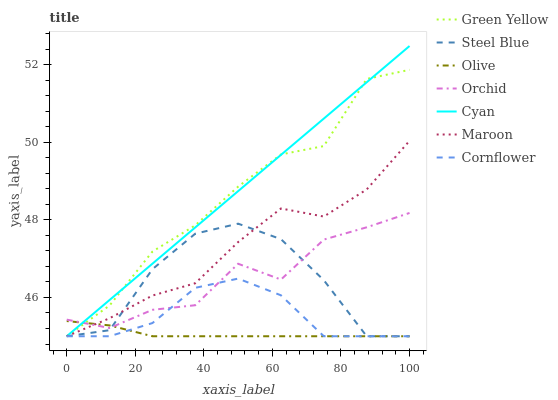Does Olive have the minimum area under the curve?
Answer yes or no. Yes. Does Cyan have the maximum area under the curve?
Answer yes or no. Yes. Does Steel Blue have the minimum area under the curve?
Answer yes or no. No. Does Steel Blue have the maximum area under the curve?
Answer yes or no. No. Is Cyan the smoothest?
Answer yes or no. Yes. Is Steel Blue the roughest?
Answer yes or no. Yes. Is Maroon the smoothest?
Answer yes or no. No. Is Maroon the roughest?
Answer yes or no. No. Does Cornflower have the lowest value?
Answer yes or no. Yes. Does Orchid have the lowest value?
Answer yes or no. No. Does Cyan have the highest value?
Answer yes or no. Yes. Does Steel Blue have the highest value?
Answer yes or no. No. Does Maroon intersect Orchid?
Answer yes or no. Yes. Is Maroon less than Orchid?
Answer yes or no. No. Is Maroon greater than Orchid?
Answer yes or no. No. 